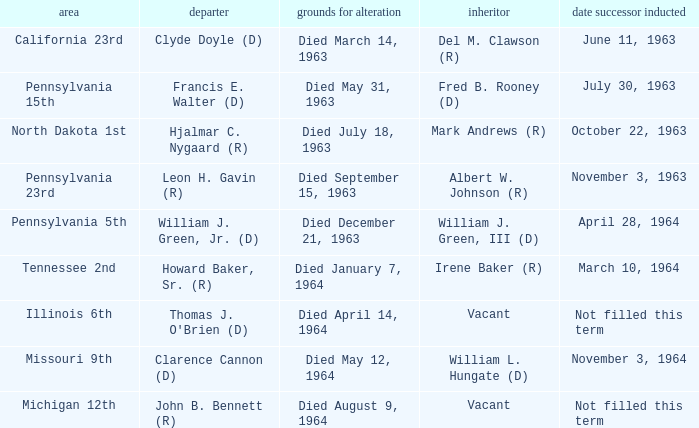Who are all successors when reason for change is died May 12, 1964? William L. Hungate (D). 